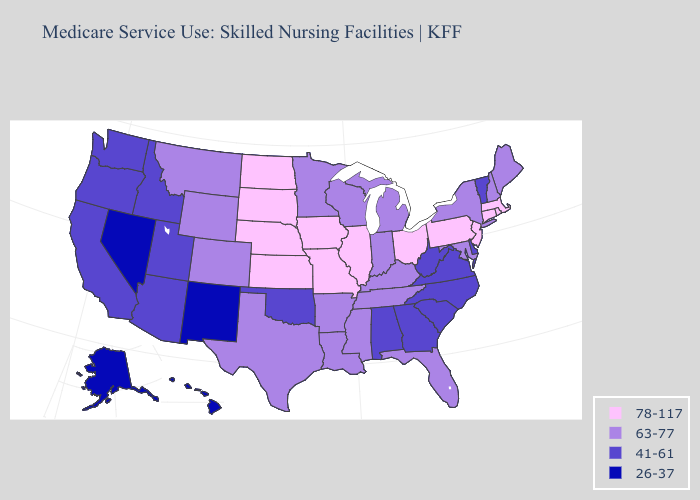Name the states that have a value in the range 41-61?
Concise answer only. Alabama, Arizona, California, Delaware, Georgia, Idaho, North Carolina, Oklahoma, Oregon, South Carolina, Utah, Vermont, Virginia, Washington, West Virginia. Name the states that have a value in the range 63-77?
Keep it brief. Arkansas, Colorado, Florida, Indiana, Kentucky, Louisiana, Maine, Maryland, Michigan, Minnesota, Mississippi, Montana, New Hampshire, New York, Tennessee, Texas, Wisconsin, Wyoming. What is the highest value in the South ?
Write a very short answer. 63-77. What is the value of Oklahoma?
Answer briefly. 41-61. Name the states that have a value in the range 41-61?
Give a very brief answer. Alabama, Arizona, California, Delaware, Georgia, Idaho, North Carolina, Oklahoma, Oregon, South Carolina, Utah, Vermont, Virginia, Washington, West Virginia. Does Texas have the same value as Tennessee?
Give a very brief answer. Yes. Name the states that have a value in the range 63-77?
Keep it brief. Arkansas, Colorado, Florida, Indiana, Kentucky, Louisiana, Maine, Maryland, Michigan, Minnesota, Mississippi, Montana, New Hampshire, New York, Tennessee, Texas, Wisconsin, Wyoming. Name the states that have a value in the range 63-77?
Concise answer only. Arkansas, Colorado, Florida, Indiana, Kentucky, Louisiana, Maine, Maryland, Michigan, Minnesota, Mississippi, Montana, New Hampshire, New York, Tennessee, Texas, Wisconsin, Wyoming. What is the value of Michigan?
Answer briefly. 63-77. Name the states that have a value in the range 26-37?
Short answer required. Alaska, Hawaii, Nevada, New Mexico. What is the highest value in states that border Arizona?
Give a very brief answer. 63-77. Does Minnesota have the lowest value in the MidWest?
Be succinct. Yes. Among the states that border Massachusetts , which have the lowest value?
Short answer required. Vermont. Does Nebraska have the highest value in the USA?
Quick response, please. Yes. What is the highest value in states that border Oregon?
Write a very short answer. 41-61. 